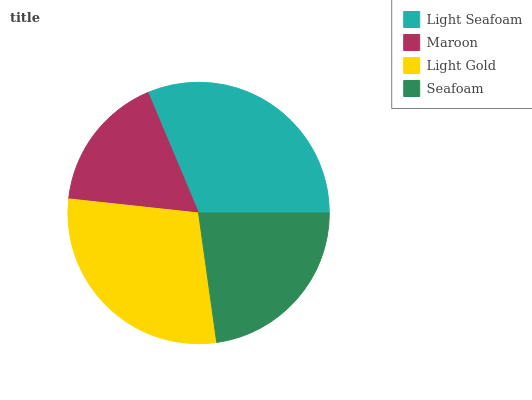Is Maroon the minimum?
Answer yes or no. Yes. Is Light Seafoam the maximum?
Answer yes or no. Yes. Is Light Gold the minimum?
Answer yes or no. No. Is Light Gold the maximum?
Answer yes or no. No. Is Light Gold greater than Maroon?
Answer yes or no. Yes. Is Maroon less than Light Gold?
Answer yes or no. Yes. Is Maroon greater than Light Gold?
Answer yes or no. No. Is Light Gold less than Maroon?
Answer yes or no. No. Is Light Gold the high median?
Answer yes or no. Yes. Is Seafoam the low median?
Answer yes or no. Yes. Is Seafoam the high median?
Answer yes or no. No. Is Light Seafoam the low median?
Answer yes or no. No. 